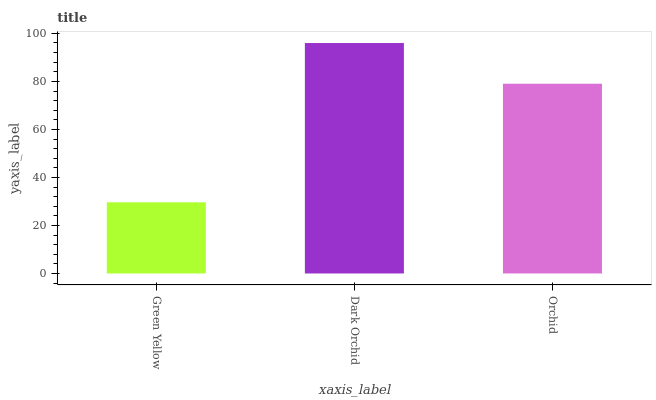Is Green Yellow the minimum?
Answer yes or no. Yes. Is Dark Orchid the maximum?
Answer yes or no. Yes. Is Orchid the minimum?
Answer yes or no. No. Is Orchid the maximum?
Answer yes or no. No. Is Dark Orchid greater than Orchid?
Answer yes or no. Yes. Is Orchid less than Dark Orchid?
Answer yes or no. Yes. Is Orchid greater than Dark Orchid?
Answer yes or no. No. Is Dark Orchid less than Orchid?
Answer yes or no. No. Is Orchid the high median?
Answer yes or no. Yes. Is Orchid the low median?
Answer yes or no. Yes. Is Dark Orchid the high median?
Answer yes or no. No. Is Dark Orchid the low median?
Answer yes or no. No. 